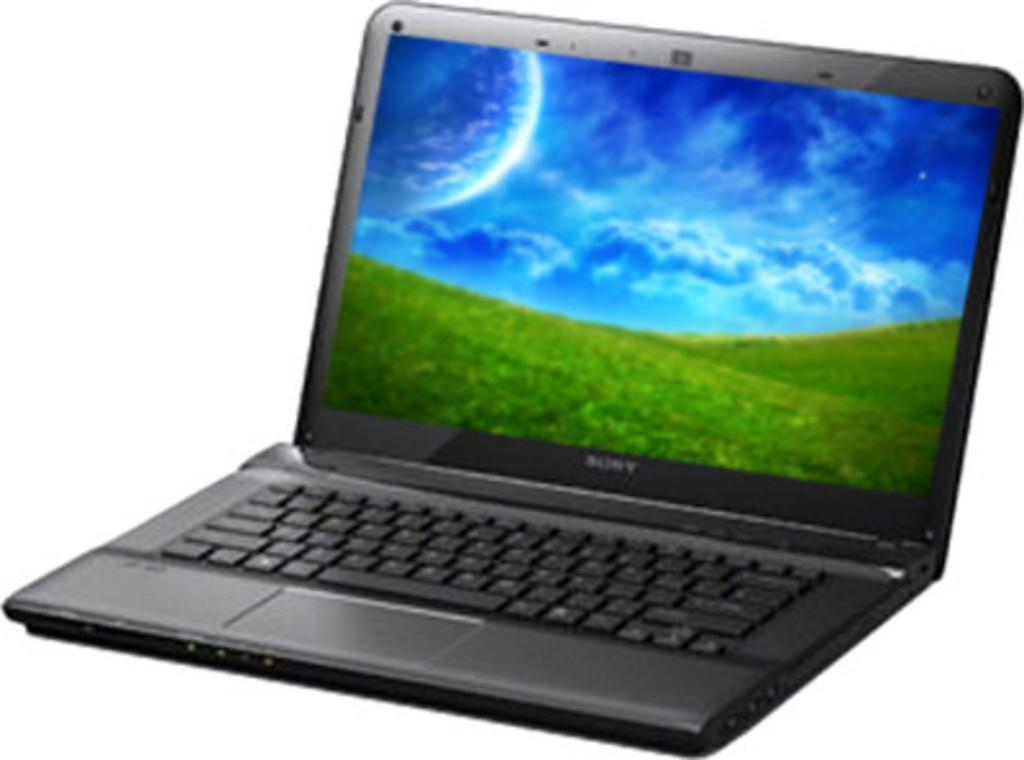<image>
Share a concise interpretation of the image provided. A grey Sony laptop with a cloudy sky and grassy mountains on the screen 